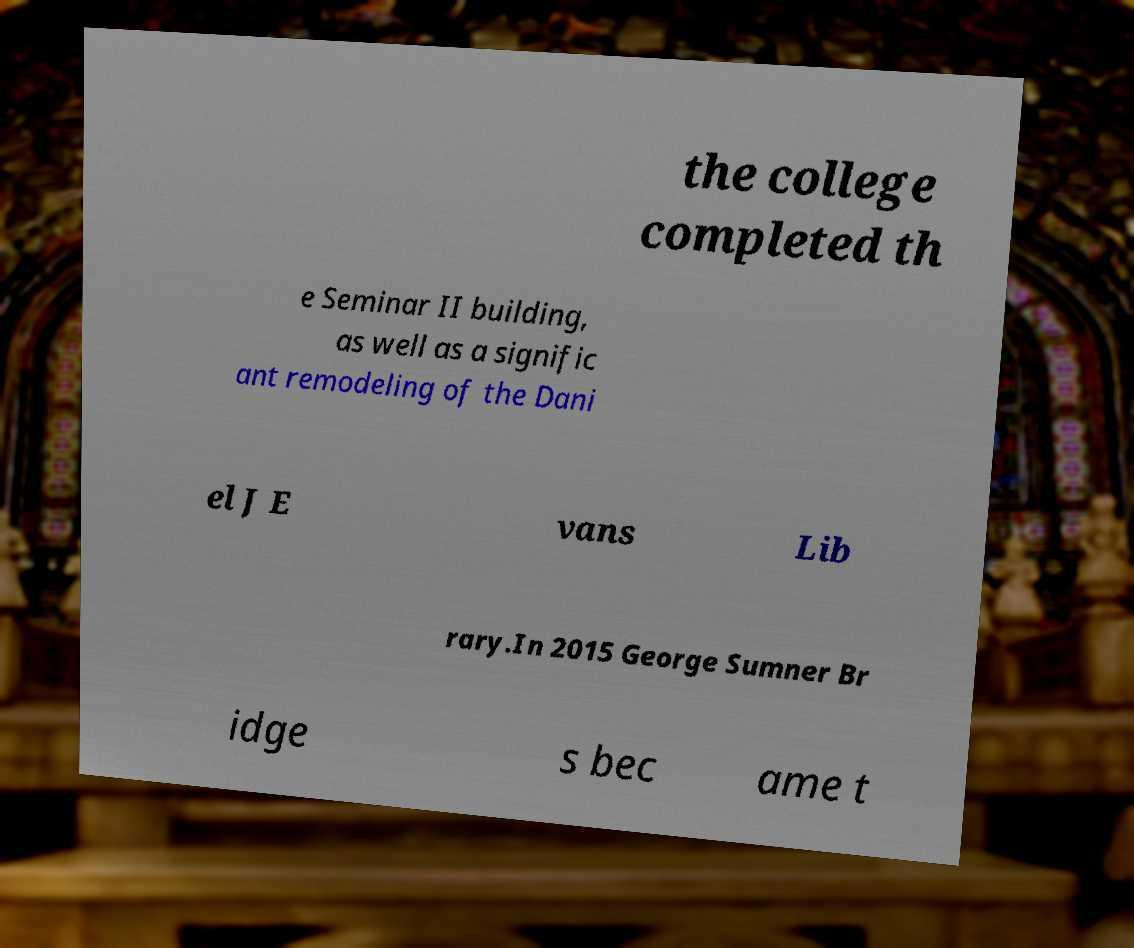Please read and relay the text visible in this image. What does it say? the college completed th e Seminar II building, as well as a signific ant remodeling of the Dani el J E vans Lib rary.In 2015 George Sumner Br idge s bec ame t 